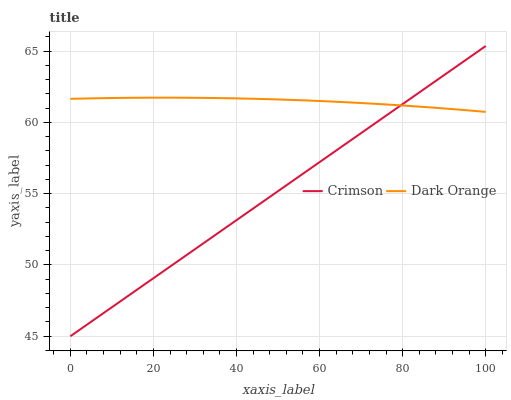Does Crimson have the minimum area under the curve?
Answer yes or no. Yes. Does Dark Orange have the maximum area under the curve?
Answer yes or no. Yes. Does Dark Orange have the minimum area under the curve?
Answer yes or no. No. Is Crimson the smoothest?
Answer yes or no. Yes. Is Dark Orange the roughest?
Answer yes or no. Yes. Is Dark Orange the smoothest?
Answer yes or no. No. Does Crimson have the lowest value?
Answer yes or no. Yes. Does Dark Orange have the lowest value?
Answer yes or no. No. Does Crimson have the highest value?
Answer yes or no. Yes. Does Dark Orange have the highest value?
Answer yes or no. No. Does Dark Orange intersect Crimson?
Answer yes or no. Yes. Is Dark Orange less than Crimson?
Answer yes or no. No. Is Dark Orange greater than Crimson?
Answer yes or no. No. 